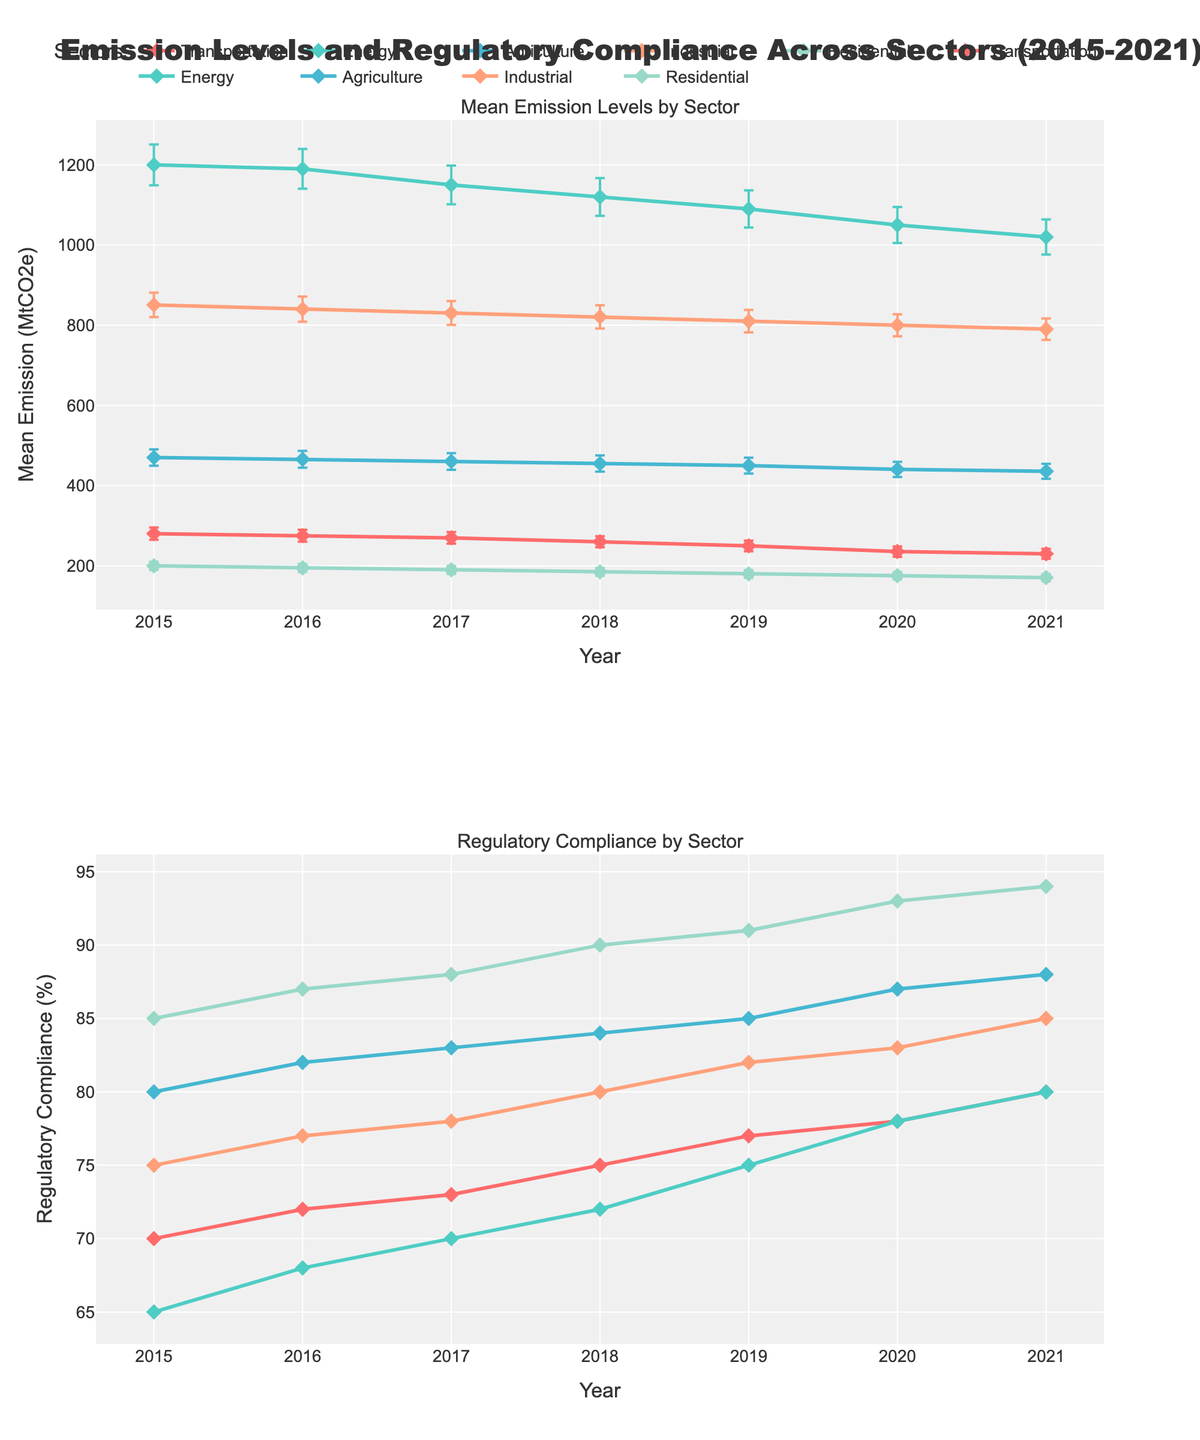How many years of data are represented in the figure? The x-axis spans from 2015 to 2021, showing data for each year within this range. Count each year to determine the total number.
Answer: 7 Which sector had the highest mean emission level in 2015? According to the top subplot, the Energy sector had the highest mean emission level in 2015. Its emission level is clearly higher than those of the other sectors, with a mean value of 1200 MtCO2e.
Answer: Energy What's the overall trend in mean emissions for the Transportation sector from 2015 to 2021? Observing the mean emissions for the Transportation sector on the top subplot, the trend shows a steady decrease over the years. In 2015, the mean emission is around 280.5 MtCO2e, which consistently declines to reach approximately 230.2 MtCO2e by 2021.
Answer: Steady decrease Which sector shows the highest regulatory compliance in 2021? The bottom subplot indicates regulatory compliance levels by sector. In 2021, the Residential sector has the highest compliance level at 94%.
Answer: Residential Compare the regulatory compliance between the Agriculture and Industrial sectors in 2020. Look at the bottom subplot for the year 2020. The Agriculture sector has a regulatory compliance level of 87%, while the Industrial sector's compliance is 83%. Therefore, the Agriculture sector has a higher compliance level.
Answer: Agriculture What is the mean emission level for the Residential sector in 2017, and what is its error margin? For the Residential sector in 2017 on the top subplot, the mean emission level is approximately 190.1 MtCO2e. The error bar indicates a standard deviation of about 9.9 MtCO2e.
Answer: Mean: 190.1 MtCO2e, Error margin: ±9.9 MtCO2e Among all sectors, which one experienced the largest reduction in mean emissions from 2015 to 2021? To find the largest reduction, calculate the difference in mean emissions from 2015 to 2021 for each sector:  
Transportation: 280.5 - 230.2 = 50.3 MtCO2e  
Energy: 1200 - 1020 = 180 MtCO2e  
Agriculture: 470.3 - 435.9 = 34.4 MtCO2e  
Industrial: 850.7 - 790.3 = 60.4 MtCO2e  
Residential: 200.1 - 170.8 = 29.3 MtCO2e  
The Energy sector has the largest reduction of 180 MtCO2e.
Answer: Energy How does the error margin for the Energy sector in 2019 compare to other sectors in the same year? In the top subplot for 2019, the Energy sector has an error margin of 46.5 MtCO2e. Observe the error bars of the other sectors:  
Transportation: 13.3 MtCO2e  
Agriculture: 19.8 MtCO2e  
Industrial: 28.1 MtCO2e  
Residential: 9.5 MtCO2e  
The Energy sector has the largest error margin among all sectors.
Answer: Largest Between 2018 and 2019, which sector saw an increase in regulatory compliance? Looking at the bottom subplot for the years 2018 and 2019, the Industrial sector's regulatory compliance increased from 80% to 82%. The other sectors either remained constant or decreased in compliance rates during this period.
Answer: Industrial 